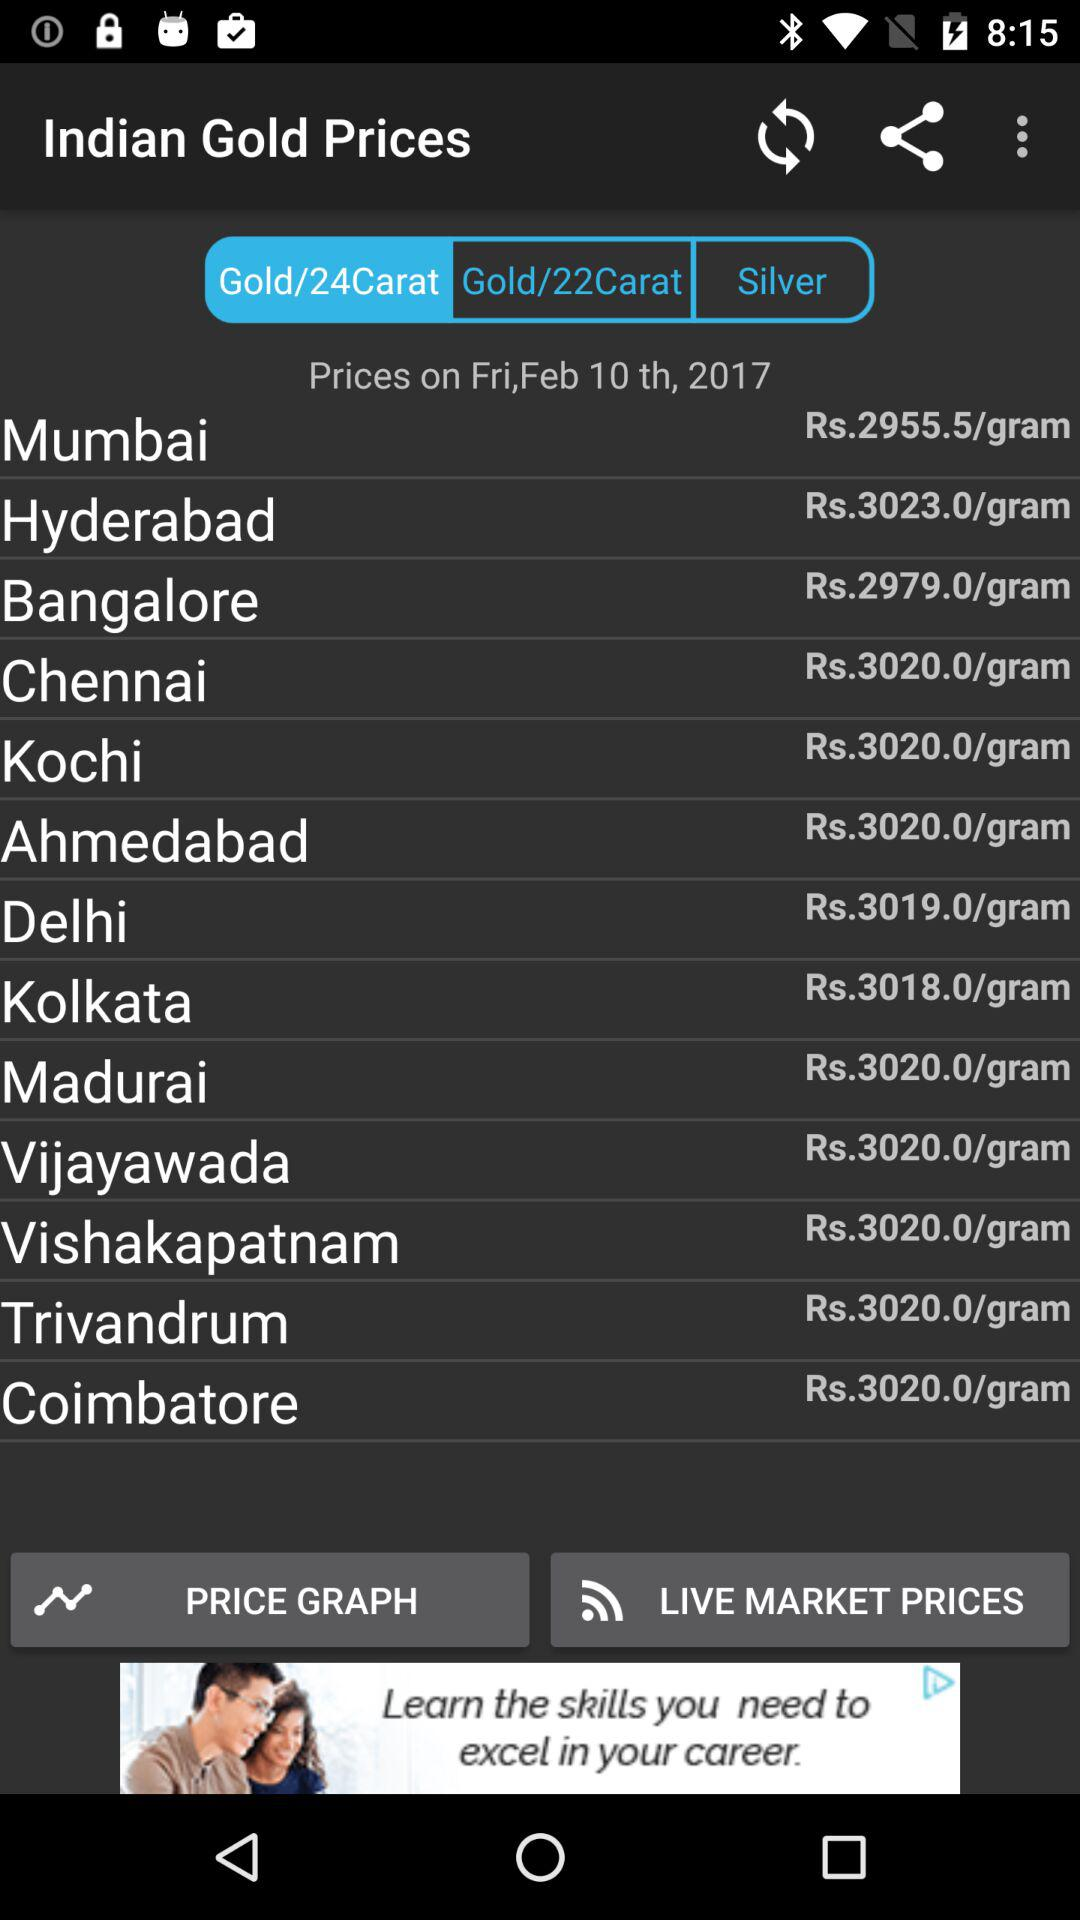Which tab are we on? You are on the "Gold/24Carat" tab. 